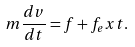<formula> <loc_0><loc_0><loc_500><loc_500>m \frac { d v } { d t } = f + f _ { e } x t .</formula> 